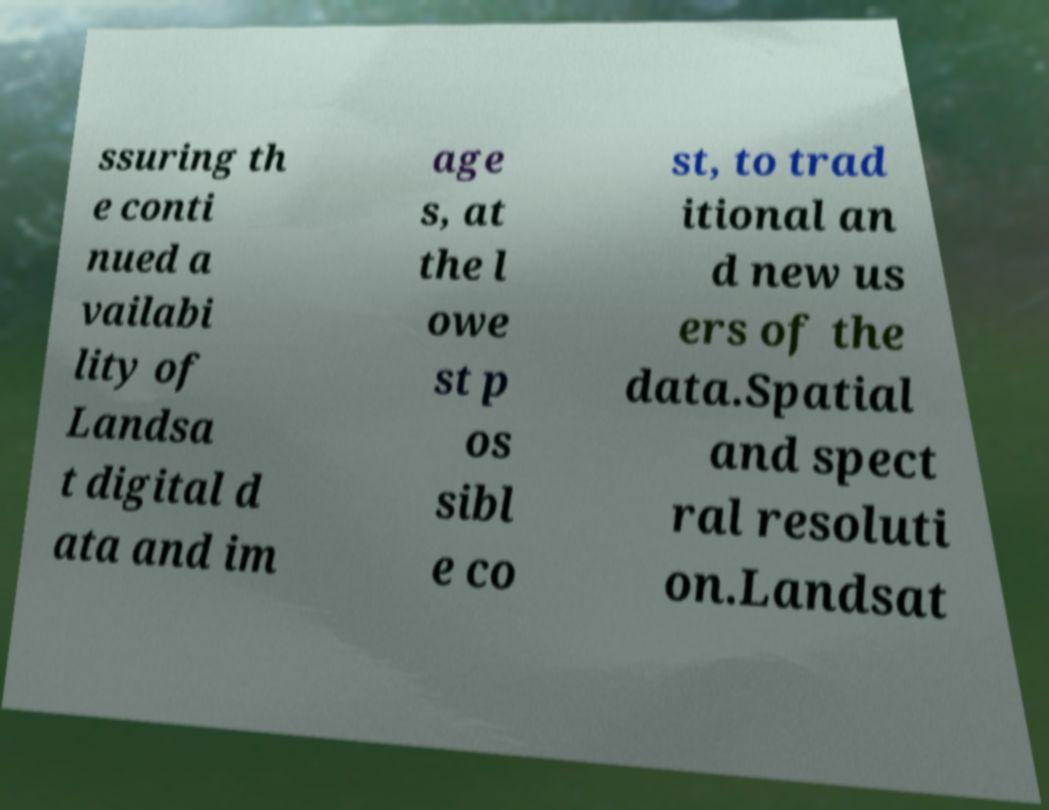Could you assist in decoding the text presented in this image and type it out clearly? ssuring th e conti nued a vailabi lity of Landsa t digital d ata and im age s, at the l owe st p os sibl e co st, to trad itional an d new us ers of the data.Spatial and spect ral resoluti on.Landsat 